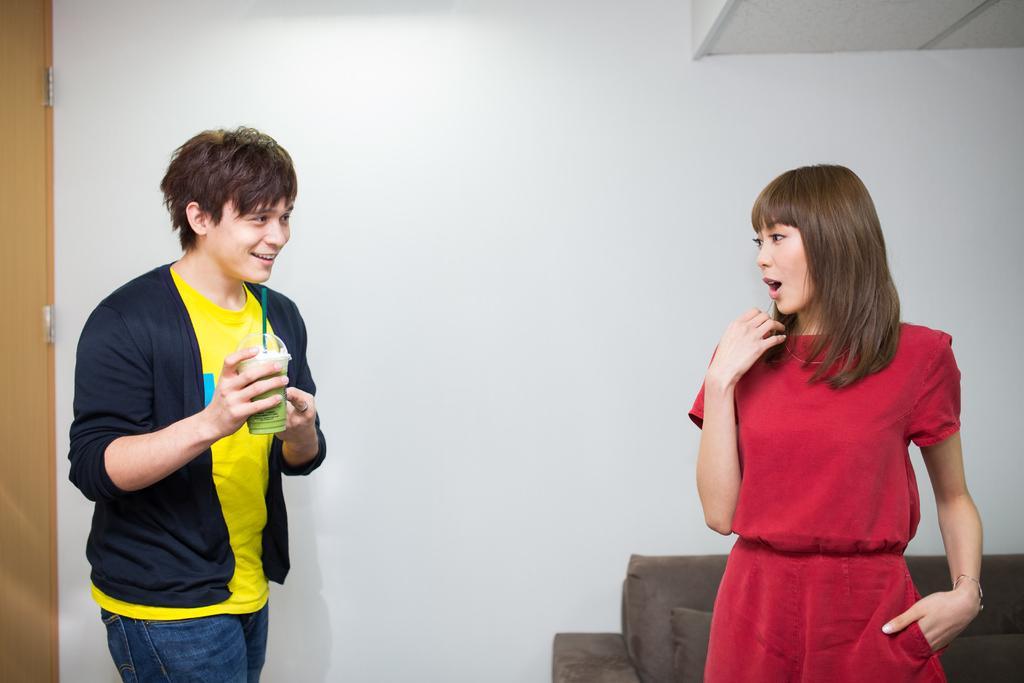How would you summarize this image in a sentence or two? In this image we can see a man and a woman standing. In that a man is holding a glass with a straw. On the backside we can see a couch, door and a wall. 